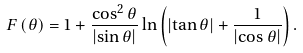Convert formula to latex. <formula><loc_0><loc_0><loc_500><loc_500>F \left ( \theta \right ) = 1 + \frac { \cos ^ { 2 } \theta } { \left | \sin \theta \right | } \ln \left ( \left | \tan \theta \right | + \frac { 1 } { \left | \cos \theta \right | } \right ) .</formula> 